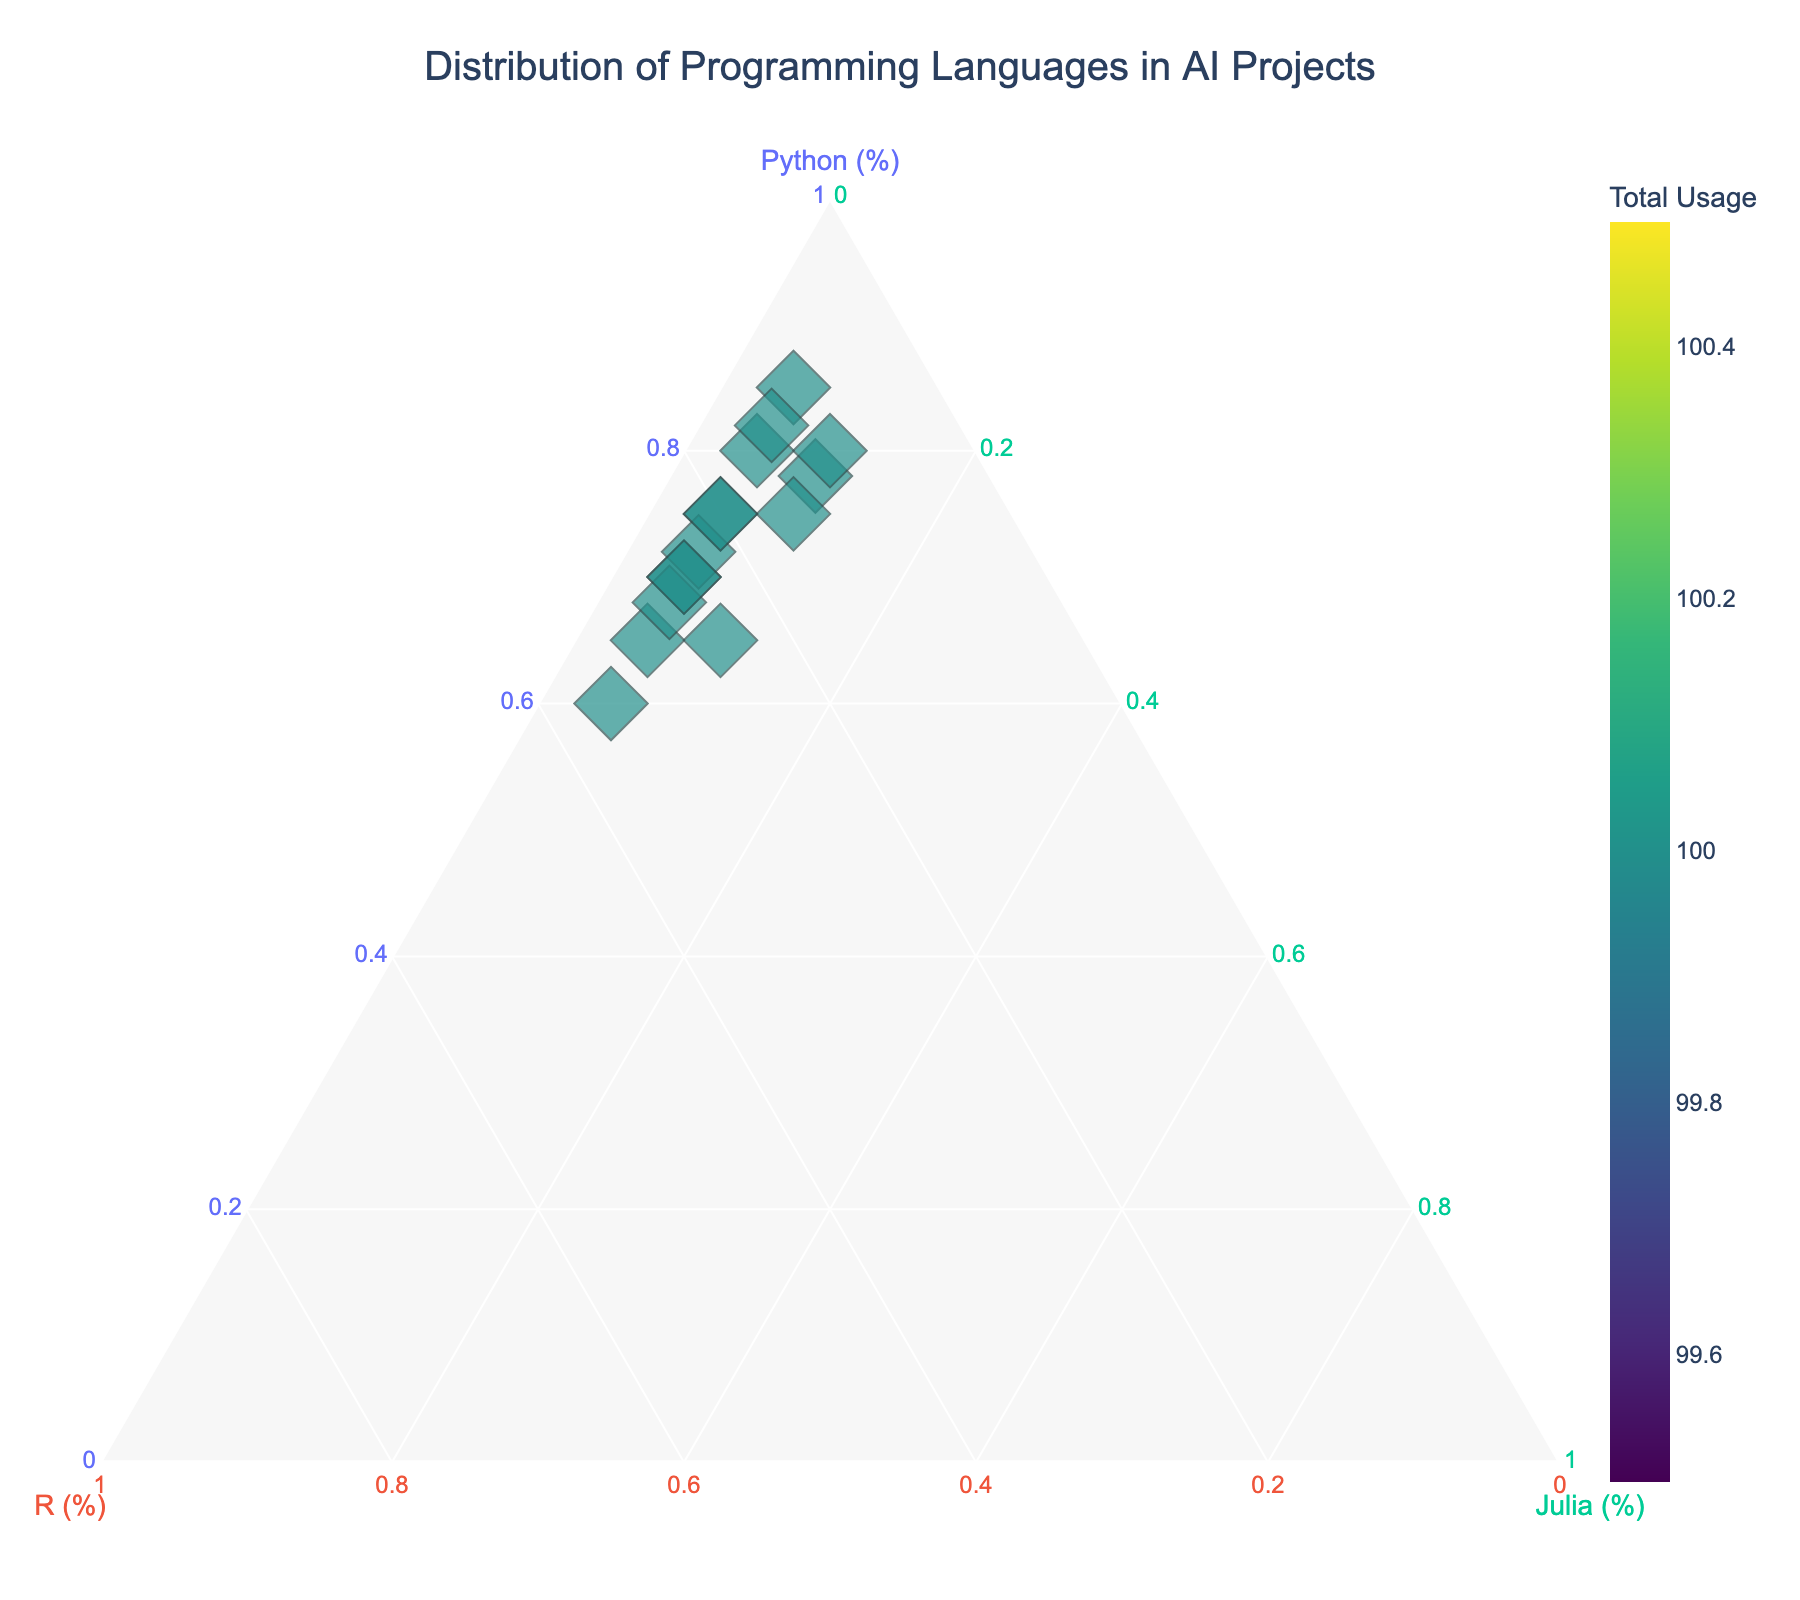How many distinct AI projects are represented in the figure? Count the number of distinct project names shown in the figure. Each project represents one point on the ternary plot.
Answer: 15 What colors are used to differentiate the points based on total usage? The points are colored using a gradient from the "Viridis" color scale, which ranges from dark blue to yellow. The specific color indicates the total usage of Python, R, and Julia in each project.
Answer: Dark blue to yellow Which project uses the highest percentage of Python? The label "Keras Neural Networks" is located furthest towards the Python corner, indicating it has the highest percentage of Python usage.
Answer: Keras Neural Networks Which project has equal usage of R and Julia? By examining the locations of the points, the "Optuna Hyperparameter Tuning" project appears to have equal or very close percentages of R and Julia.
Answer: Optuna Hyperparameter Tuning Which corner of the ternary plot has the highest concentration of points? The Python corner (bottom left) has the highest concentration of points indicating that more AI projects use a higher percentage of Python.
Answer: Python corner What is the average percentage of Python used across all projects? Sum all Python percentage values and divide by the number of projects: (80 + 75 + 70 + 85 + 78 + 65 + 60 + 72 + 68 + 75 + 82 + 80 + 70 + 75 + 65) / 15.
Answer: 72.27% Which project uses the minimal percentage of Julia? By checking the distances from the Julia corner (top right), most projects have a low percentage of Julia, with "TensorFlow Implementation", "OpenAI GPT Fine-tuning", "Scikit-learn Models", and several others at 5%.
Answer: TensorFlow Implementation, OpenAI GPT Fine-tuning, Scikit-learn Models, and others (5%) How do the projects "FastAI Deep Learning" and "PyTorch Computer Vision" compare in terms of Python and Julia percentages? "FastAI Deep Learning" has 80% Python and 10% Julia. "PyTorch Computer Vision" has 78% Python and 10% Julia. Both use the same percentage of Julia, but "FastAI Deep Learning" uses a slightly higher percentage of Python.
Answer: FastAI Deep Learning has more Python What does a point located in the exact center of the ternary plot represent? It would represent a project using equal percentages (33.33%) of Python, R, and Julia.
Answer: Equal usage (33.33%) of Python, R, and Julia How is the data size visualized in this ternary plot? All points are shown with the same size, represented by markers of constant size (e.g., diamonds) irrespective of the data size.
Answer: Constant size markers 